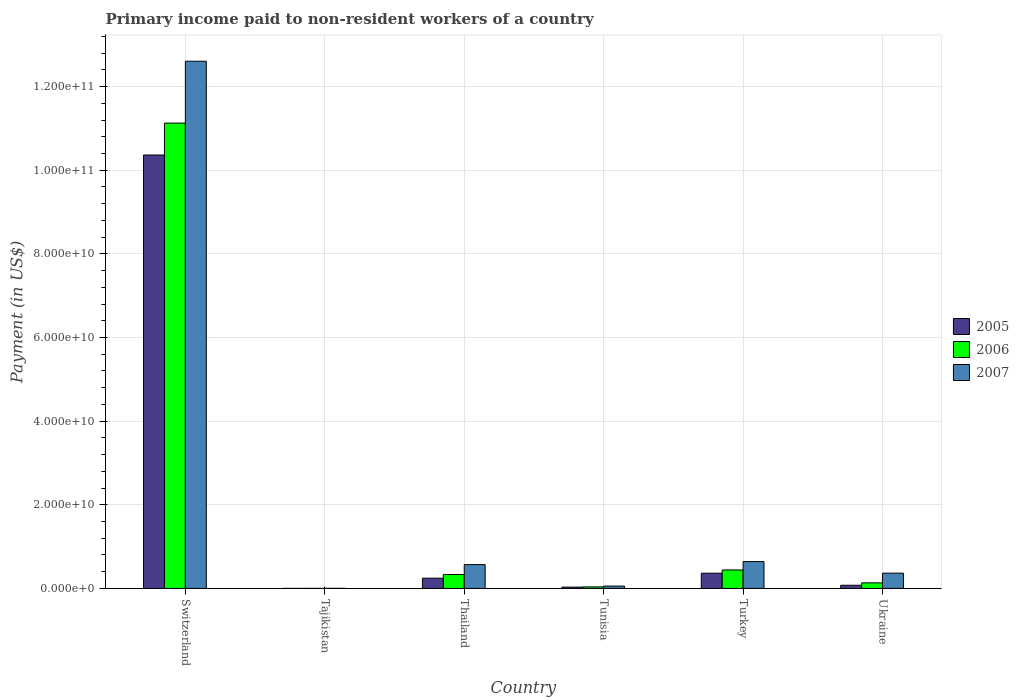How many different coloured bars are there?
Offer a terse response. 3. Are the number of bars on each tick of the X-axis equal?
Your response must be concise. Yes. What is the label of the 2nd group of bars from the left?
Ensure brevity in your answer.  Tajikistan. In how many cases, is the number of bars for a given country not equal to the number of legend labels?
Offer a very short reply. 0. What is the amount paid to workers in 2006 in Ukraine?
Provide a short and direct response. 1.33e+09. Across all countries, what is the maximum amount paid to workers in 2007?
Your answer should be very brief. 1.26e+11. Across all countries, what is the minimum amount paid to workers in 2005?
Offer a very short reply. 9.59e+06. In which country was the amount paid to workers in 2005 maximum?
Give a very brief answer. Switzerland. In which country was the amount paid to workers in 2006 minimum?
Your response must be concise. Tajikistan. What is the total amount paid to workers in 2007 in the graph?
Ensure brevity in your answer.  1.42e+11. What is the difference between the amount paid to workers in 2007 in Switzerland and that in Tunisia?
Give a very brief answer. 1.25e+11. What is the difference between the amount paid to workers in 2007 in Thailand and the amount paid to workers in 2005 in Tunisia?
Offer a terse response. 5.38e+09. What is the average amount paid to workers in 2006 per country?
Offer a terse response. 2.01e+1. What is the difference between the amount paid to workers of/in 2005 and amount paid to workers of/in 2006 in Ukraine?
Provide a short and direct response. -5.74e+08. What is the ratio of the amount paid to workers in 2006 in Tunisia to that in Turkey?
Provide a succinct answer. 0.08. Is the amount paid to workers in 2005 in Thailand less than that in Ukraine?
Provide a succinct answer. No. What is the difference between the highest and the second highest amount paid to workers in 2006?
Your answer should be very brief. 1.07e+11. What is the difference between the highest and the lowest amount paid to workers in 2005?
Your response must be concise. 1.04e+11. In how many countries, is the amount paid to workers in 2007 greater than the average amount paid to workers in 2007 taken over all countries?
Your response must be concise. 1. Is the sum of the amount paid to workers in 2005 in Switzerland and Turkey greater than the maximum amount paid to workers in 2007 across all countries?
Your answer should be compact. No. Are all the bars in the graph horizontal?
Your response must be concise. No. How many countries are there in the graph?
Offer a terse response. 6. What is the difference between two consecutive major ticks on the Y-axis?
Ensure brevity in your answer.  2.00e+1. Are the values on the major ticks of Y-axis written in scientific E-notation?
Make the answer very short. Yes. Does the graph contain grids?
Offer a terse response. Yes. How are the legend labels stacked?
Your answer should be very brief. Vertical. What is the title of the graph?
Provide a succinct answer. Primary income paid to non-resident workers of a country. Does "2004" appear as one of the legend labels in the graph?
Make the answer very short. No. What is the label or title of the X-axis?
Your answer should be compact. Country. What is the label or title of the Y-axis?
Your answer should be very brief. Payment (in US$). What is the Payment (in US$) of 2005 in Switzerland?
Keep it short and to the point. 1.04e+11. What is the Payment (in US$) of 2006 in Switzerland?
Provide a succinct answer. 1.11e+11. What is the Payment (in US$) in 2007 in Switzerland?
Ensure brevity in your answer.  1.26e+11. What is the Payment (in US$) of 2005 in Tajikistan?
Offer a very short reply. 9.59e+06. What is the Payment (in US$) of 2006 in Tajikistan?
Provide a short and direct response. 1.24e+07. What is the Payment (in US$) of 2007 in Tajikistan?
Make the answer very short. 2.24e+07. What is the Payment (in US$) in 2005 in Thailand?
Make the answer very short. 2.45e+09. What is the Payment (in US$) of 2006 in Thailand?
Your response must be concise. 3.33e+09. What is the Payment (in US$) in 2007 in Thailand?
Your response must be concise. 5.70e+09. What is the Payment (in US$) of 2005 in Tunisia?
Your response must be concise. 3.16e+08. What is the Payment (in US$) in 2006 in Tunisia?
Provide a short and direct response. 3.67e+08. What is the Payment (in US$) in 2007 in Tunisia?
Offer a terse response. 5.63e+08. What is the Payment (in US$) of 2005 in Turkey?
Give a very brief answer. 3.64e+09. What is the Payment (in US$) in 2006 in Turkey?
Keep it short and to the point. 4.42e+09. What is the Payment (in US$) in 2007 in Turkey?
Your answer should be very brief. 6.42e+09. What is the Payment (in US$) of 2005 in Ukraine?
Keep it short and to the point. 7.58e+08. What is the Payment (in US$) of 2006 in Ukraine?
Offer a very short reply. 1.33e+09. What is the Payment (in US$) of 2007 in Ukraine?
Offer a terse response. 3.66e+09. Across all countries, what is the maximum Payment (in US$) in 2005?
Provide a short and direct response. 1.04e+11. Across all countries, what is the maximum Payment (in US$) of 2006?
Your answer should be very brief. 1.11e+11. Across all countries, what is the maximum Payment (in US$) of 2007?
Keep it short and to the point. 1.26e+11. Across all countries, what is the minimum Payment (in US$) in 2005?
Keep it short and to the point. 9.59e+06. Across all countries, what is the minimum Payment (in US$) of 2006?
Your response must be concise. 1.24e+07. Across all countries, what is the minimum Payment (in US$) of 2007?
Keep it short and to the point. 2.24e+07. What is the total Payment (in US$) in 2005 in the graph?
Make the answer very short. 1.11e+11. What is the total Payment (in US$) of 2006 in the graph?
Provide a succinct answer. 1.21e+11. What is the total Payment (in US$) in 2007 in the graph?
Ensure brevity in your answer.  1.42e+11. What is the difference between the Payment (in US$) of 2005 in Switzerland and that in Tajikistan?
Keep it short and to the point. 1.04e+11. What is the difference between the Payment (in US$) in 2006 in Switzerland and that in Tajikistan?
Make the answer very short. 1.11e+11. What is the difference between the Payment (in US$) in 2007 in Switzerland and that in Tajikistan?
Your answer should be very brief. 1.26e+11. What is the difference between the Payment (in US$) of 2005 in Switzerland and that in Thailand?
Ensure brevity in your answer.  1.01e+11. What is the difference between the Payment (in US$) of 2006 in Switzerland and that in Thailand?
Keep it short and to the point. 1.08e+11. What is the difference between the Payment (in US$) in 2007 in Switzerland and that in Thailand?
Keep it short and to the point. 1.20e+11. What is the difference between the Payment (in US$) in 2005 in Switzerland and that in Tunisia?
Keep it short and to the point. 1.03e+11. What is the difference between the Payment (in US$) of 2006 in Switzerland and that in Tunisia?
Offer a very short reply. 1.11e+11. What is the difference between the Payment (in US$) of 2007 in Switzerland and that in Tunisia?
Offer a terse response. 1.25e+11. What is the difference between the Payment (in US$) in 2005 in Switzerland and that in Turkey?
Offer a terse response. 1.00e+11. What is the difference between the Payment (in US$) in 2006 in Switzerland and that in Turkey?
Provide a succinct answer. 1.07e+11. What is the difference between the Payment (in US$) in 2007 in Switzerland and that in Turkey?
Keep it short and to the point. 1.20e+11. What is the difference between the Payment (in US$) of 2005 in Switzerland and that in Ukraine?
Offer a terse response. 1.03e+11. What is the difference between the Payment (in US$) in 2006 in Switzerland and that in Ukraine?
Provide a short and direct response. 1.10e+11. What is the difference between the Payment (in US$) in 2007 in Switzerland and that in Ukraine?
Your answer should be compact. 1.22e+11. What is the difference between the Payment (in US$) in 2005 in Tajikistan and that in Thailand?
Make the answer very short. -2.44e+09. What is the difference between the Payment (in US$) in 2006 in Tajikistan and that in Thailand?
Your answer should be very brief. -3.32e+09. What is the difference between the Payment (in US$) in 2007 in Tajikistan and that in Thailand?
Provide a succinct answer. -5.68e+09. What is the difference between the Payment (in US$) in 2005 in Tajikistan and that in Tunisia?
Keep it short and to the point. -3.06e+08. What is the difference between the Payment (in US$) in 2006 in Tajikistan and that in Tunisia?
Provide a succinct answer. -3.54e+08. What is the difference between the Payment (in US$) of 2007 in Tajikistan and that in Tunisia?
Your answer should be very brief. -5.40e+08. What is the difference between the Payment (in US$) of 2005 in Tajikistan and that in Turkey?
Keep it short and to the point. -3.63e+09. What is the difference between the Payment (in US$) in 2006 in Tajikistan and that in Turkey?
Ensure brevity in your answer.  -4.41e+09. What is the difference between the Payment (in US$) of 2007 in Tajikistan and that in Turkey?
Your response must be concise. -6.40e+09. What is the difference between the Payment (in US$) in 2005 in Tajikistan and that in Ukraine?
Ensure brevity in your answer.  -7.48e+08. What is the difference between the Payment (in US$) in 2006 in Tajikistan and that in Ukraine?
Make the answer very short. -1.32e+09. What is the difference between the Payment (in US$) of 2007 in Tajikistan and that in Ukraine?
Give a very brief answer. -3.63e+09. What is the difference between the Payment (in US$) in 2005 in Thailand and that in Tunisia?
Make the answer very short. 2.14e+09. What is the difference between the Payment (in US$) of 2006 in Thailand and that in Tunisia?
Your answer should be compact. 2.97e+09. What is the difference between the Payment (in US$) of 2007 in Thailand and that in Tunisia?
Ensure brevity in your answer.  5.13e+09. What is the difference between the Payment (in US$) in 2005 in Thailand and that in Turkey?
Offer a terse response. -1.19e+09. What is the difference between the Payment (in US$) in 2006 in Thailand and that in Turkey?
Keep it short and to the point. -1.09e+09. What is the difference between the Payment (in US$) of 2007 in Thailand and that in Turkey?
Provide a short and direct response. -7.25e+08. What is the difference between the Payment (in US$) of 2005 in Thailand and that in Ukraine?
Offer a terse response. 1.69e+09. What is the difference between the Payment (in US$) in 2006 in Thailand and that in Ukraine?
Provide a short and direct response. 2.00e+09. What is the difference between the Payment (in US$) of 2007 in Thailand and that in Ukraine?
Provide a short and direct response. 2.04e+09. What is the difference between the Payment (in US$) in 2005 in Tunisia and that in Turkey?
Offer a terse response. -3.33e+09. What is the difference between the Payment (in US$) in 2006 in Tunisia and that in Turkey?
Your response must be concise. -4.05e+09. What is the difference between the Payment (in US$) in 2007 in Tunisia and that in Turkey?
Provide a succinct answer. -5.86e+09. What is the difference between the Payment (in US$) in 2005 in Tunisia and that in Ukraine?
Your answer should be compact. -4.42e+08. What is the difference between the Payment (in US$) in 2006 in Tunisia and that in Ukraine?
Your response must be concise. -9.65e+08. What is the difference between the Payment (in US$) of 2007 in Tunisia and that in Ukraine?
Keep it short and to the point. -3.09e+09. What is the difference between the Payment (in US$) of 2005 in Turkey and that in Ukraine?
Provide a short and direct response. 2.89e+09. What is the difference between the Payment (in US$) in 2006 in Turkey and that in Ukraine?
Provide a short and direct response. 3.09e+09. What is the difference between the Payment (in US$) of 2007 in Turkey and that in Ukraine?
Offer a terse response. 2.77e+09. What is the difference between the Payment (in US$) in 2005 in Switzerland and the Payment (in US$) in 2006 in Tajikistan?
Offer a terse response. 1.04e+11. What is the difference between the Payment (in US$) in 2005 in Switzerland and the Payment (in US$) in 2007 in Tajikistan?
Give a very brief answer. 1.04e+11. What is the difference between the Payment (in US$) of 2006 in Switzerland and the Payment (in US$) of 2007 in Tajikistan?
Your answer should be compact. 1.11e+11. What is the difference between the Payment (in US$) in 2005 in Switzerland and the Payment (in US$) in 2006 in Thailand?
Ensure brevity in your answer.  1.00e+11. What is the difference between the Payment (in US$) in 2005 in Switzerland and the Payment (in US$) in 2007 in Thailand?
Give a very brief answer. 9.79e+1. What is the difference between the Payment (in US$) of 2006 in Switzerland and the Payment (in US$) of 2007 in Thailand?
Make the answer very short. 1.06e+11. What is the difference between the Payment (in US$) in 2005 in Switzerland and the Payment (in US$) in 2006 in Tunisia?
Ensure brevity in your answer.  1.03e+11. What is the difference between the Payment (in US$) in 2005 in Switzerland and the Payment (in US$) in 2007 in Tunisia?
Keep it short and to the point. 1.03e+11. What is the difference between the Payment (in US$) of 2006 in Switzerland and the Payment (in US$) of 2007 in Tunisia?
Your answer should be very brief. 1.11e+11. What is the difference between the Payment (in US$) of 2005 in Switzerland and the Payment (in US$) of 2006 in Turkey?
Your answer should be compact. 9.92e+1. What is the difference between the Payment (in US$) in 2005 in Switzerland and the Payment (in US$) in 2007 in Turkey?
Offer a terse response. 9.72e+1. What is the difference between the Payment (in US$) of 2006 in Switzerland and the Payment (in US$) of 2007 in Turkey?
Offer a terse response. 1.05e+11. What is the difference between the Payment (in US$) of 2005 in Switzerland and the Payment (in US$) of 2006 in Ukraine?
Your answer should be very brief. 1.02e+11. What is the difference between the Payment (in US$) of 2005 in Switzerland and the Payment (in US$) of 2007 in Ukraine?
Ensure brevity in your answer.  1.00e+11. What is the difference between the Payment (in US$) of 2006 in Switzerland and the Payment (in US$) of 2007 in Ukraine?
Offer a very short reply. 1.08e+11. What is the difference between the Payment (in US$) in 2005 in Tajikistan and the Payment (in US$) in 2006 in Thailand?
Ensure brevity in your answer.  -3.32e+09. What is the difference between the Payment (in US$) in 2005 in Tajikistan and the Payment (in US$) in 2007 in Thailand?
Ensure brevity in your answer.  -5.69e+09. What is the difference between the Payment (in US$) in 2006 in Tajikistan and the Payment (in US$) in 2007 in Thailand?
Your response must be concise. -5.69e+09. What is the difference between the Payment (in US$) in 2005 in Tajikistan and the Payment (in US$) in 2006 in Tunisia?
Ensure brevity in your answer.  -3.57e+08. What is the difference between the Payment (in US$) of 2005 in Tajikistan and the Payment (in US$) of 2007 in Tunisia?
Ensure brevity in your answer.  -5.53e+08. What is the difference between the Payment (in US$) in 2006 in Tajikistan and the Payment (in US$) in 2007 in Tunisia?
Your response must be concise. -5.50e+08. What is the difference between the Payment (in US$) in 2005 in Tajikistan and the Payment (in US$) in 2006 in Turkey?
Your answer should be compact. -4.41e+09. What is the difference between the Payment (in US$) of 2005 in Tajikistan and the Payment (in US$) of 2007 in Turkey?
Provide a short and direct response. -6.41e+09. What is the difference between the Payment (in US$) in 2006 in Tajikistan and the Payment (in US$) in 2007 in Turkey?
Provide a succinct answer. -6.41e+09. What is the difference between the Payment (in US$) in 2005 in Tajikistan and the Payment (in US$) in 2006 in Ukraine?
Provide a short and direct response. -1.32e+09. What is the difference between the Payment (in US$) in 2005 in Tajikistan and the Payment (in US$) in 2007 in Ukraine?
Offer a terse response. -3.65e+09. What is the difference between the Payment (in US$) of 2006 in Tajikistan and the Payment (in US$) of 2007 in Ukraine?
Offer a terse response. -3.64e+09. What is the difference between the Payment (in US$) of 2005 in Thailand and the Payment (in US$) of 2006 in Tunisia?
Provide a short and direct response. 2.09e+09. What is the difference between the Payment (in US$) of 2005 in Thailand and the Payment (in US$) of 2007 in Tunisia?
Give a very brief answer. 1.89e+09. What is the difference between the Payment (in US$) of 2006 in Thailand and the Payment (in US$) of 2007 in Tunisia?
Make the answer very short. 2.77e+09. What is the difference between the Payment (in US$) of 2005 in Thailand and the Payment (in US$) of 2006 in Turkey?
Provide a succinct answer. -1.97e+09. What is the difference between the Payment (in US$) in 2005 in Thailand and the Payment (in US$) in 2007 in Turkey?
Offer a terse response. -3.97e+09. What is the difference between the Payment (in US$) of 2006 in Thailand and the Payment (in US$) of 2007 in Turkey?
Offer a very short reply. -3.09e+09. What is the difference between the Payment (in US$) in 2005 in Thailand and the Payment (in US$) in 2006 in Ukraine?
Your answer should be compact. 1.12e+09. What is the difference between the Payment (in US$) of 2005 in Thailand and the Payment (in US$) of 2007 in Ukraine?
Keep it short and to the point. -1.20e+09. What is the difference between the Payment (in US$) in 2006 in Thailand and the Payment (in US$) in 2007 in Ukraine?
Offer a very short reply. -3.24e+08. What is the difference between the Payment (in US$) in 2005 in Tunisia and the Payment (in US$) in 2006 in Turkey?
Your response must be concise. -4.10e+09. What is the difference between the Payment (in US$) in 2005 in Tunisia and the Payment (in US$) in 2007 in Turkey?
Keep it short and to the point. -6.11e+09. What is the difference between the Payment (in US$) of 2006 in Tunisia and the Payment (in US$) of 2007 in Turkey?
Offer a terse response. -6.06e+09. What is the difference between the Payment (in US$) of 2005 in Tunisia and the Payment (in US$) of 2006 in Ukraine?
Provide a succinct answer. -1.02e+09. What is the difference between the Payment (in US$) of 2005 in Tunisia and the Payment (in US$) of 2007 in Ukraine?
Provide a short and direct response. -3.34e+09. What is the difference between the Payment (in US$) in 2006 in Tunisia and the Payment (in US$) in 2007 in Ukraine?
Keep it short and to the point. -3.29e+09. What is the difference between the Payment (in US$) of 2005 in Turkey and the Payment (in US$) of 2006 in Ukraine?
Offer a very short reply. 2.31e+09. What is the difference between the Payment (in US$) of 2005 in Turkey and the Payment (in US$) of 2007 in Ukraine?
Keep it short and to the point. -1.20e+07. What is the difference between the Payment (in US$) in 2006 in Turkey and the Payment (in US$) in 2007 in Ukraine?
Give a very brief answer. 7.62e+08. What is the average Payment (in US$) in 2005 per country?
Give a very brief answer. 1.85e+1. What is the average Payment (in US$) in 2006 per country?
Provide a short and direct response. 2.01e+1. What is the average Payment (in US$) of 2007 per country?
Your answer should be very brief. 2.37e+1. What is the difference between the Payment (in US$) in 2005 and Payment (in US$) in 2006 in Switzerland?
Make the answer very short. -7.63e+09. What is the difference between the Payment (in US$) of 2005 and Payment (in US$) of 2007 in Switzerland?
Keep it short and to the point. -2.24e+1. What is the difference between the Payment (in US$) of 2006 and Payment (in US$) of 2007 in Switzerland?
Keep it short and to the point. -1.48e+1. What is the difference between the Payment (in US$) of 2005 and Payment (in US$) of 2006 in Tajikistan?
Offer a very short reply. -2.84e+06. What is the difference between the Payment (in US$) of 2005 and Payment (in US$) of 2007 in Tajikistan?
Give a very brief answer. -1.28e+07. What is the difference between the Payment (in US$) in 2006 and Payment (in US$) in 2007 in Tajikistan?
Offer a terse response. -1.00e+07. What is the difference between the Payment (in US$) in 2005 and Payment (in US$) in 2006 in Thailand?
Provide a short and direct response. -8.80e+08. What is the difference between the Payment (in US$) in 2005 and Payment (in US$) in 2007 in Thailand?
Provide a short and direct response. -3.24e+09. What is the difference between the Payment (in US$) in 2006 and Payment (in US$) in 2007 in Thailand?
Provide a short and direct response. -2.37e+09. What is the difference between the Payment (in US$) in 2005 and Payment (in US$) in 2006 in Tunisia?
Your answer should be compact. -5.07e+07. What is the difference between the Payment (in US$) of 2005 and Payment (in US$) of 2007 in Tunisia?
Your answer should be compact. -2.47e+08. What is the difference between the Payment (in US$) in 2006 and Payment (in US$) in 2007 in Tunisia?
Make the answer very short. -1.96e+08. What is the difference between the Payment (in US$) of 2005 and Payment (in US$) of 2006 in Turkey?
Give a very brief answer. -7.74e+08. What is the difference between the Payment (in US$) in 2005 and Payment (in US$) in 2007 in Turkey?
Provide a succinct answer. -2.78e+09. What is the difference between the Payment (in US$) in 2006 and Payment (in US$) in 2007 in Turkey?
Provide a short and direct response. -2.00e+09. What is the difference between the Payment (in US$) in 2005 and Payment (in US$) in 2006 in Ukraine?
Offer a very short reply. -5.74e+08. What is the difference between the Payment (in US$) of 2005 and Payment (in US$) of 2007 in Ukraine?
Provide a short and direct response. -2.90e+09. What is the difference between the Payment (in US$) of 2006 and Payment (in US$) of 2007 in Ukraine?
Your answer should be compact. -2.32e+09. What is the ratio of the Payment (in US$) in 2005 in Switzerland to that in Tajikistan?
Your answer should be compact. 1.08e+04. What is the ratio of the Payment (in US$) of 2006 in Switzerland to that in Tajikistan?
Your answer should be very brief. 8953.06. What is the ratio of the Payment (in US$) in 2007 in Switzerland to that in Tajikistan?
Your answer should be very brief. 5621.28. What is the ratio of the Payment (in US$) in 2005 in Switzerland to that in Thailand?
Your answer should be compact. 42.25. What is the ratio of the Payment (in US$) of 2006 in Switzerland to that in Thailand?
Ensure brevity in your answer.  33.39. What is the ratio of the Payment (in US$) of 2007 in Switzerland to that in Thailand?
Provide a succinct answer. 22.12. What is the ratio of the Payment (in US$) in 2005 in Switzerland to that in Tunisia?
Your response must be concise. 328.1. What is the ratio of the Payment (in US$) in 2006 in Switzerland to that in Tunisia?
Provide a short and direct response. 303.54. What is the ratio of the Payment (in US$) of 2007 in Switzerland to that in Tunisia?
Ensure brevity in your answer.  224.03. What is the ratio of the Payment (in US$) in 2005 in Switzerland to that in Turkey?
Give a very brief answer. 28.44. What is the ratio of the Payment (in US$) of 2006 in Switzerland to that in Turkey?
Provide a succinct answer. 25.18. What is the ratio of the Payment (in US$) in 2007 in Switzerland to that in Turkey?
Provide a short and direct response. 19.63. What is the ratio of the Payment (in US$) in 2005 in Switzerland to that in Ukraine?
Give a very brief answer. 136.72. What is the ratio of the Payment (in US$) of 2006 in Switzerland to that in Ukraine?
Keep it short and to the point. 83.53. What is the ratio of the Payment (in US$) of 2007 in Switzerland to that in Ukraine?
Provide a succinct answer. 34.48. What is the ratio of the Payment (in US$) of 2005 in Tajikistan to that in Thailand?
Your response must be concise. 0. What is the ratio of the Payment (in US$) in 2006 in Tajikistan to that in Thailand?
Ensure brevity in your answer.  0. What is the ratio of the Payment (in US$) in 2007 in Tajikistan to that in Thailand?
Offer a terse response. 0. What is the ratio of the Payment (in US$) in 2005 in Tajikistan to that in Tunisia?
Offer a very short reply. 0.03. What is the ratio of the Payment (in US$) of 2006 in Tajikistan to that in Tunisia?
Offer a very short reply. 0.03. What is the ratio of the Payment (in US$) of 2007 in Tajikistan to that in Tunisia?
Give a very brief answer. 0.04. What is the ratio of the Payment (in US$) of 2005 in Tajikistan to that in Turkey?
Provide a succinct answer. 0. What is the ratio of the Payment (in US$) in 2006 in Tajikistan to that in Turkey?
Provide a succinct answer. 0. What is the ratio of the Payment (in US$) in 2007 in Tajikistan to that in Turkey?
Give a very brief answer. 0. What is the ratio of the Payment (in US$) of 2005 in Tajikistan to that in Ukraine?
Make the answer very short. 0.01. What is the ratio of the Payment (in US$) of 2006 in Tajikistan to that in Ukraine?
Give a very brief answer. 0.01. What is the ratio of the Payment (in US$) of 2007 in Tajikistan to that in Ukraine?
Make the answer very short. 0.01. What is the ratio of the Payment (in US$) in 2005 in Thailand to that in Tunisia?
Give a very brief answer. 7.77. What is the ratio of the Payment (in US$) in 2006 in Thailand to that in Tunisia?
Your answer should be compact. 9.09. What is the ratio of the Payment (in US$) of 2007 in Thailand to that in Tunisia?
Offer a terse response. 10.13. What is the ratio of the Payment (in US$) in 2005 in Thailand to that in Turkey?
Offer a very short reply. 0.67. What is the ratio of the Payment (in US$) of 2006 in Thailand to that in Turkey?
Provide a short and direct response. 0.75. What is the ratio of the Payment (in US$) of 2007 in Thailand to that in Turkey?
Your response must be concise. 0.89. What is the ratio of the Payment (in US$) of 2005 in Thailand to that in Ukraine?
Your answer should be very brief. 3.24. What is the ratio of the Payment (in US$) of 2006 in Thailand to that in Ukraine?
Give a very brief answer. 2.5. What is the ratio of the Payment (in US$) in 2007 in Thailand to that in Ukraine?
Your response must be concise. 1.56. What is the ratio of the Payment (in US$) of 2005 in Tunisia to that in Turkey?
Make the answer very short. 0.09. What is the ratio of the Payment (in US$) in 2006 in Tunisia to that in Turkey?
Offer a very short reply. 0.08. What is the ratio of the Payment (in US$) of 2007 in Tunisia to that in Turkey?
Make the answer very short. 0.09. What is the ratio of the Payment (in US$) of 2005 in Tunisia to that in Ukraine?
Provide a short and direct response. 0.42. What is the ratio of the Payment (in US$) of 2006 in Tunisia to that in Ukraine?
Offer a terse response. 0.28. What is the ratio of the Payment (in US$) in 2007 in Tunisia to that in Ukraine?
Your answer should be compact. 0.15. What is the ratio of the Payment (in US$) in 2005 in Turkey to that in Ukraine?
Give a very brief answer. 4.81. What is the ratio of the Payment (in US$) of 2006 in Turkey to that in Ukraine?
Your response must be concise. 3.32. What is the ratio of the Payment (in US$) of 2007 in Turkey to that in Ukraine?
Ensure brevity in your answer.  1.76. What is the difference between the highest and the second highest Payment (in US$) of 2005?
Offer a terse response. 1.00e+11. What is the difference between the highest and the second highest Payment (in US$) of 2006?
Offer a terse response. 1.07e+11. What is the difference between the highest and the second highest Payment (in US$) in 2007?
Ensure brevity in your answer.  1.20e+11. What is the difference between the highest and the lowest Payment (in US$) of 2005?
Your answer should be compact. 1.04e+11. What is the difference between the highest and the lowest Payment (in US$) of 2006?
Keep it short and to the point. 1.11e+11. What is the difference between the highest and the lowest Payment (in US$) in 2007?
Your answer should be compact. 1.26e+11. 